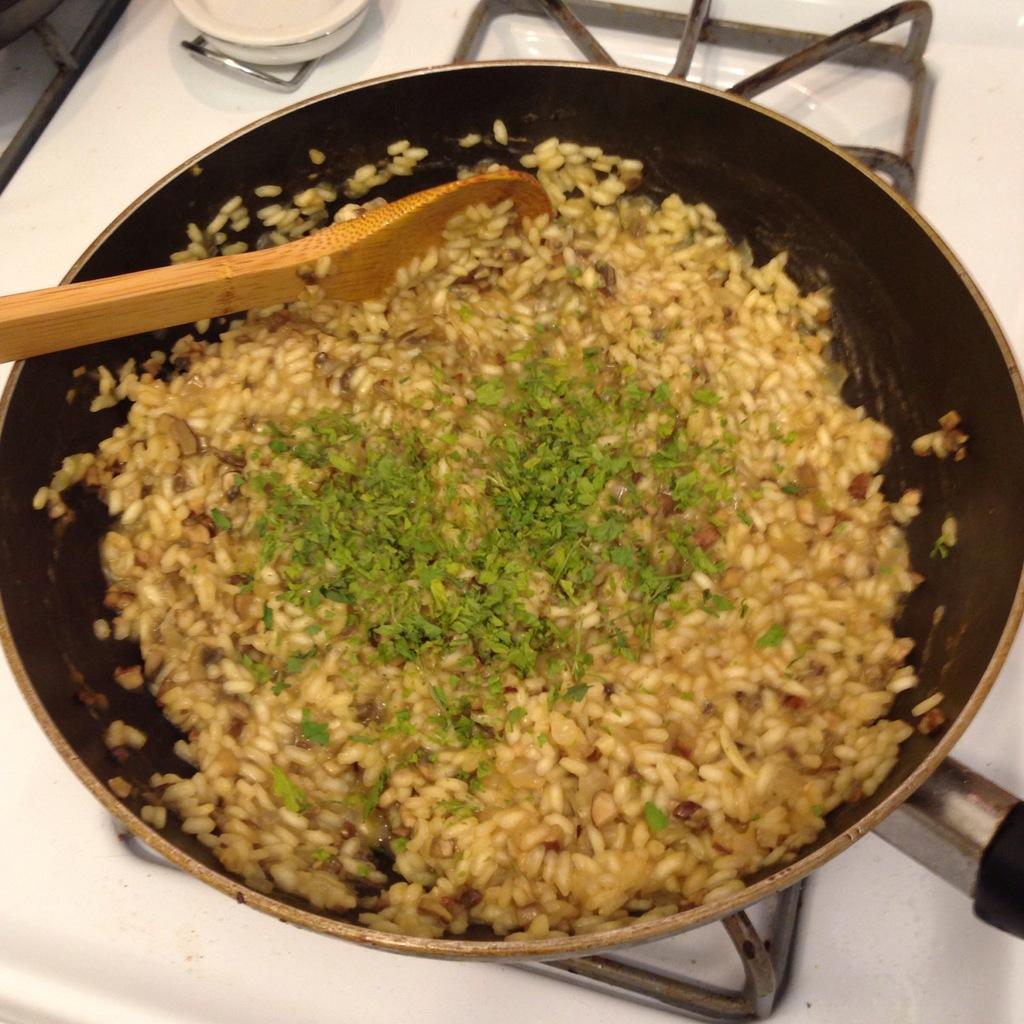Could you give a brief overview of what you see in this image? Here in this picture we can see some food item being prepared in a pan, which is present on the stove and we can also see a spoon present. 